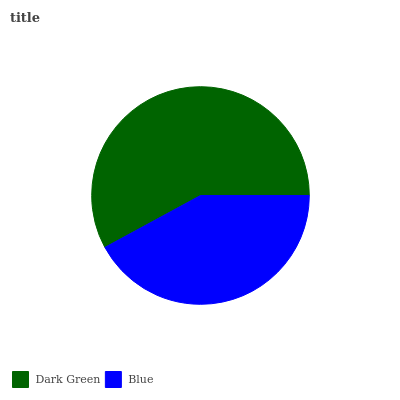Is Blue the minimum?
Answer yes or no. Yes. Is Dark Green the maximum?
Answer yes or no. Yes. Is Blue the maximum?
Answer yes or no. No. Is Dark Green greater than Blue?
Answer yes or no. Yes. Is Blue less than Dark Green?
Answer yes or no. Yes. Is Blue greater than Dark Green?
Answer yes or no. No. Is Dark Green less than Blue?
Answer yes or no. No. Is Dark Green the high median?
Answer yes or no. Yes. Is Blue the low median?
Answer yes or no. Yes. Is Blue the high median?
Answer yes or no. No. Is Dark Green the low median?
Answer yes or no. No. 